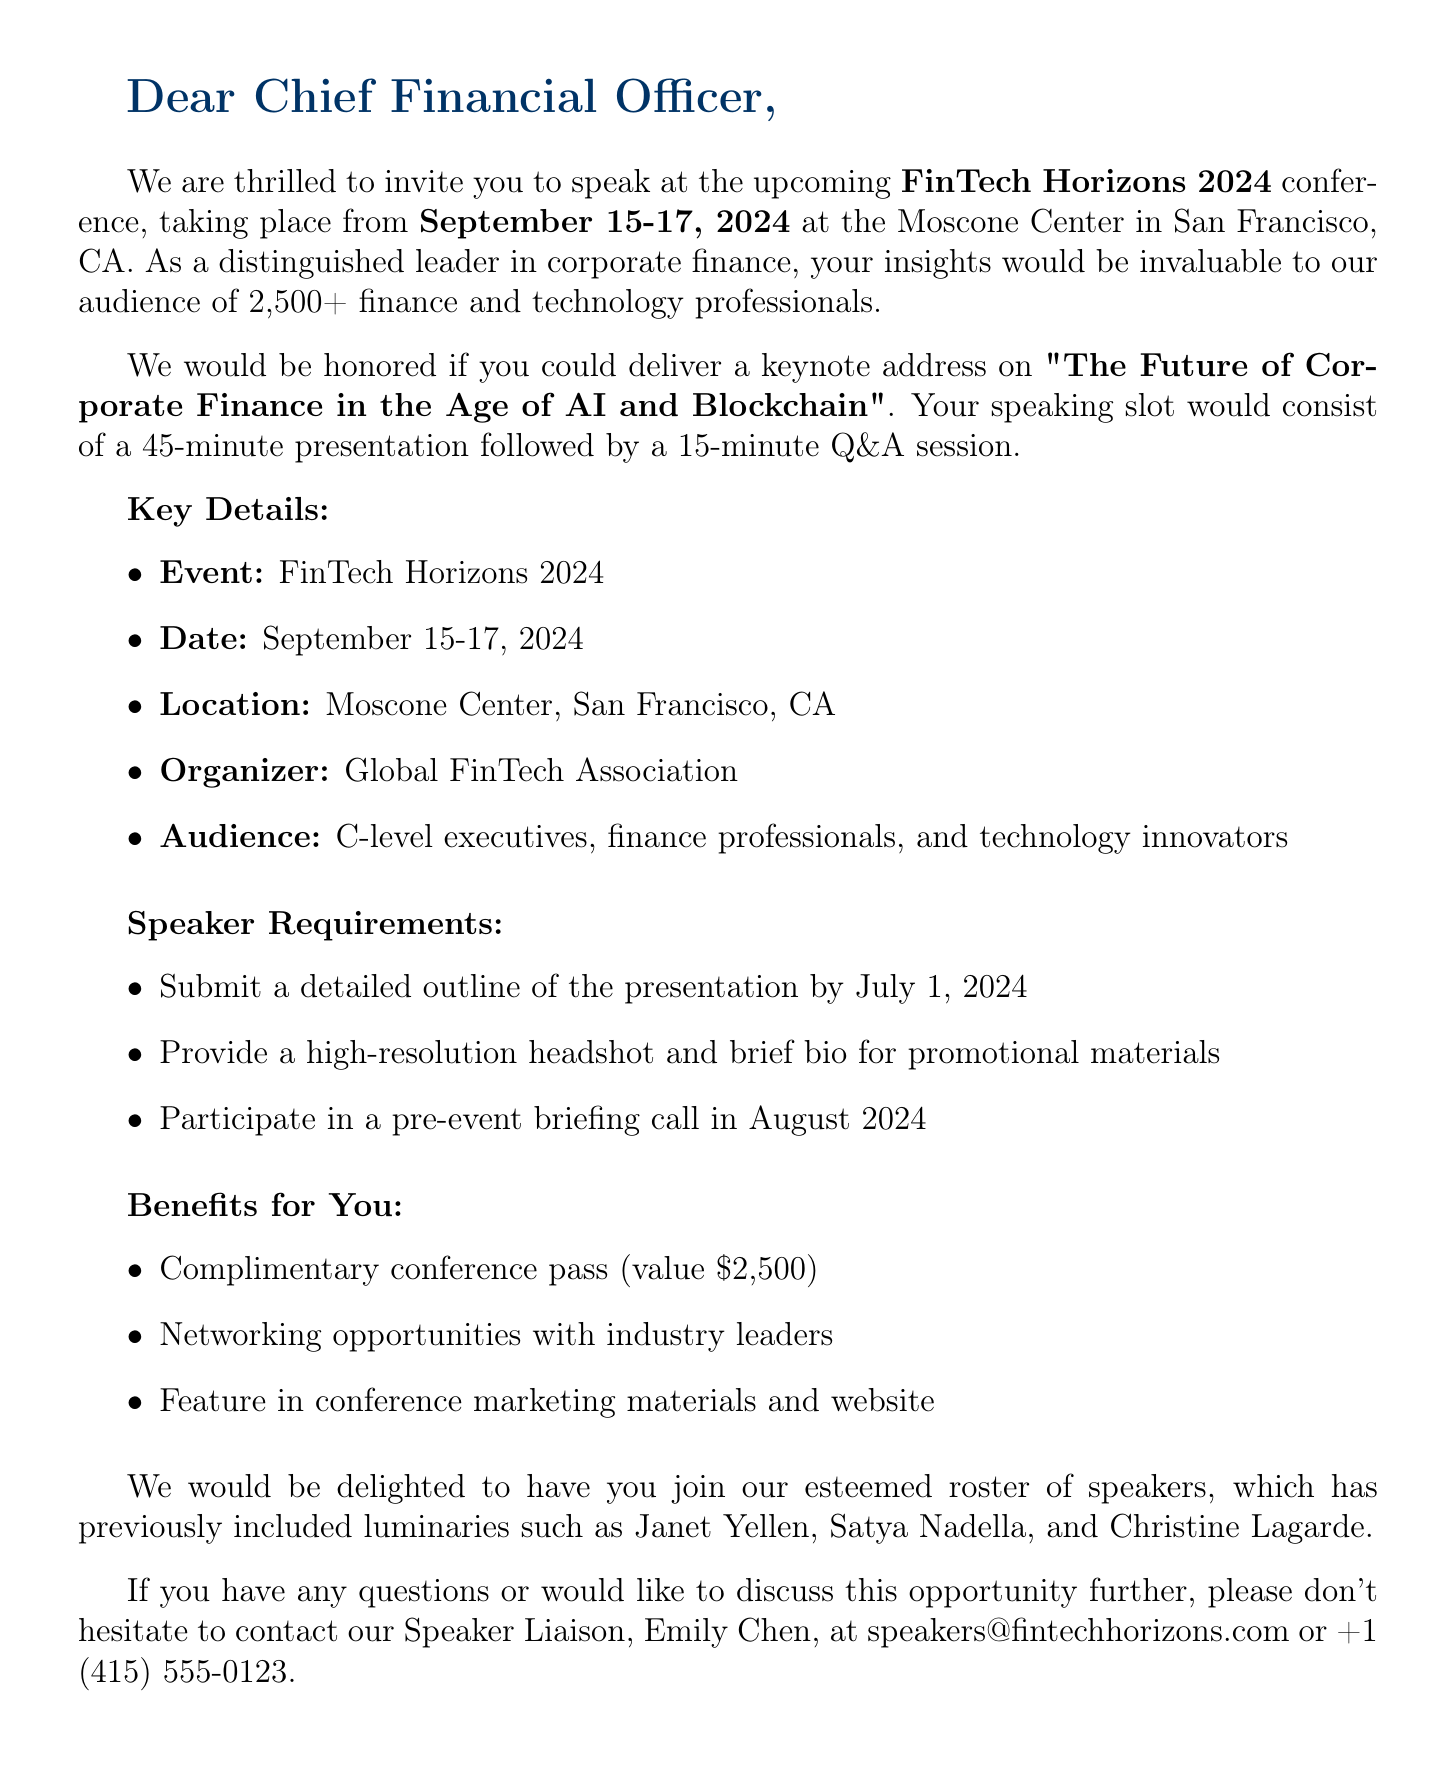What is the name of the conference? The name of the conference can be found in the introduction and is titled "FinTech Horizons 2024".
Answer: FinTech Horizons 2024 What are the dates of the event? The dates of the event are explicitly mentioned in the document.
Answer: September 15-17, 2024 Where is the conference located? The location is listed in the key details of the document.
Answer: Moscone Center, San Francisco, CA What is the expected attendance? The expected attendance information is included in the introduction of the document.
Answer: 2,500+ finance and technology professionals Who is the organizer of the event? The document specifies the organizing body of the conference.
Answer: Global FinTech Association What is included in the speaker requirements? The requirements for speakers are listed in a bullet point format in the document.
Answer: Submit a detailed outline of the presentation by July 1, 2024 What is the duration of the speaking slot? The duration of the speaking slot is clearly stated in the event details.
Answer: 45-minute presentation followed by 15-minute Q&A What benefits do speakers receive? The benefits for speakers are outlined in the document under a separate section.
Answer: Complimentary conference pass (value $2,500) Who can be contacted for more information? The contact person and their details are provided at the end of the document.
Answer: Emily Chen 